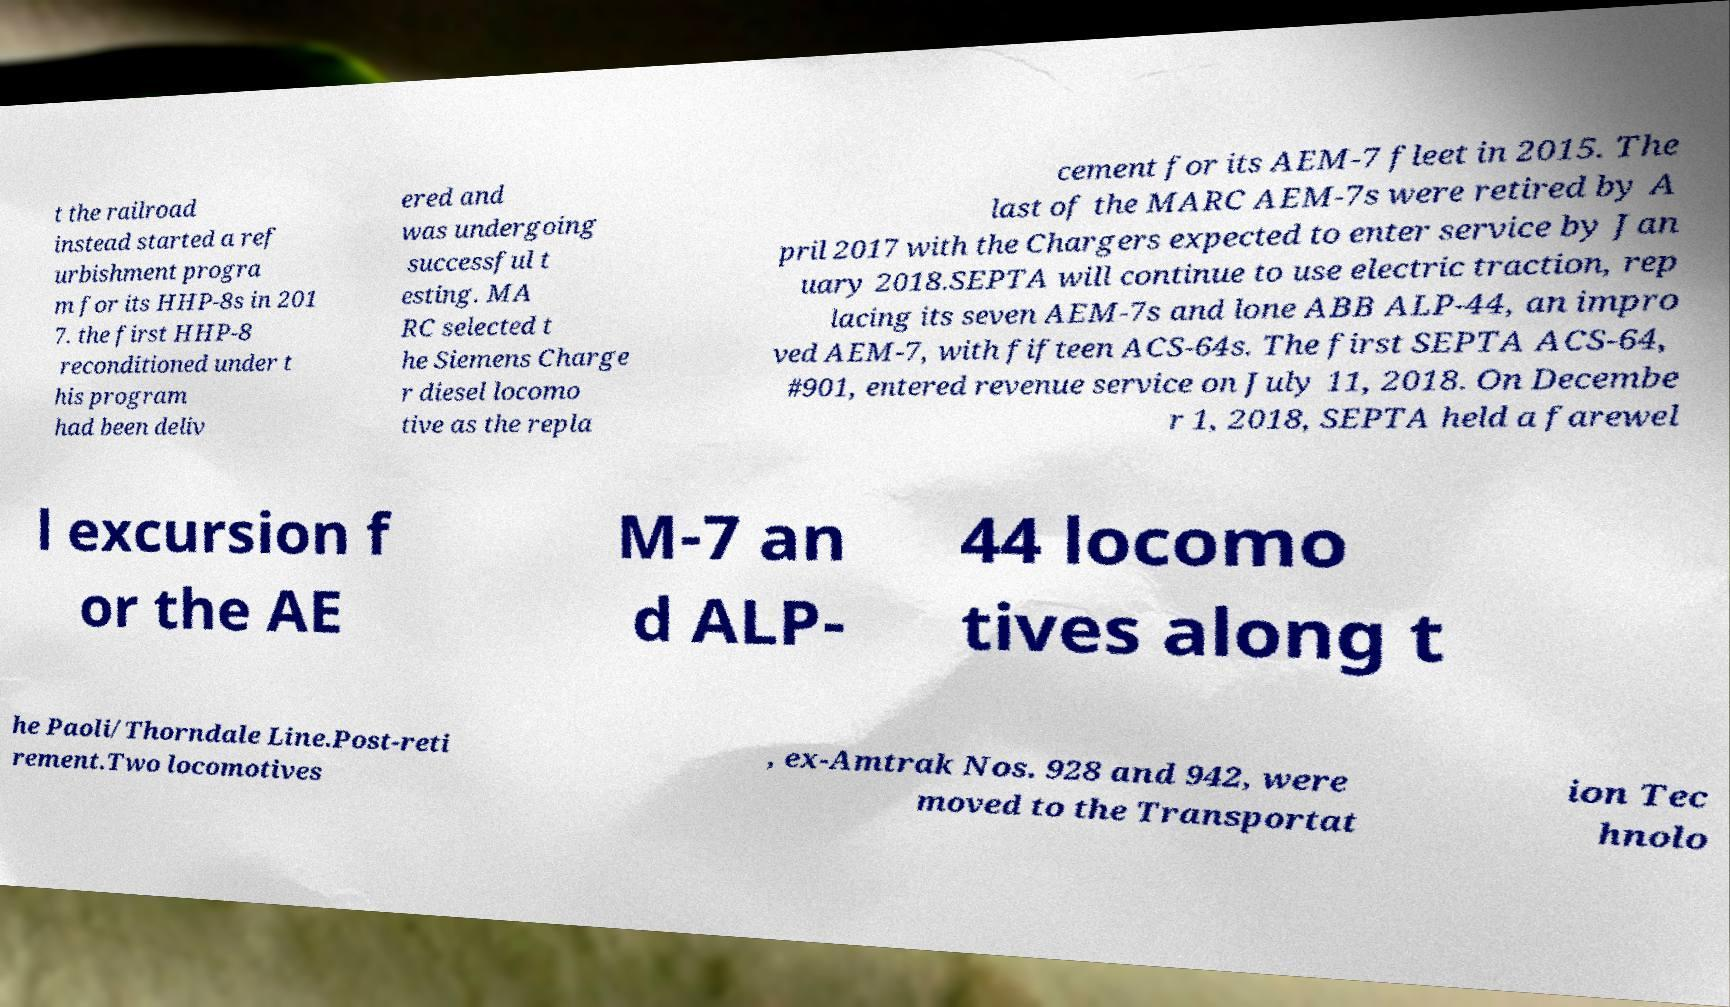Could you extract and type out the text from this image? t the railroad instead started a ref urbishment progra m for its HHP-8s in 201 7. the first HHP-8 reconditioned under t his program had been deliv ered and was undergoing successful t esting. MA RC selected t he Siemens Charge r diesel locomo tive as the repla cement for its AEM-7 fleet in 2015. The last of the MARC AEM-7s were retired by A pril 2017 with the Chargers expected to enter service by Jan uary 2018.SEPTA will continue to use electric traction, rep lacing its seven AEM-7s and lone ABB ALP-44, an impro ved AEM-7, with fifteen ACS-64s. The first SEPTA ACS-64, #901, entered revenue service on July 11, 2018. On Decembe r 1, 2018, SEPTA held a farewel l excursion f or the AE M-7 an d ALP- 44 locomo tives along t he Paoli/Thorndale Line.Post-reti rement.Two locomotives , ex-Amtrak Nos. 928 and 942, were moved to the Transportat ion Tec hnolo 